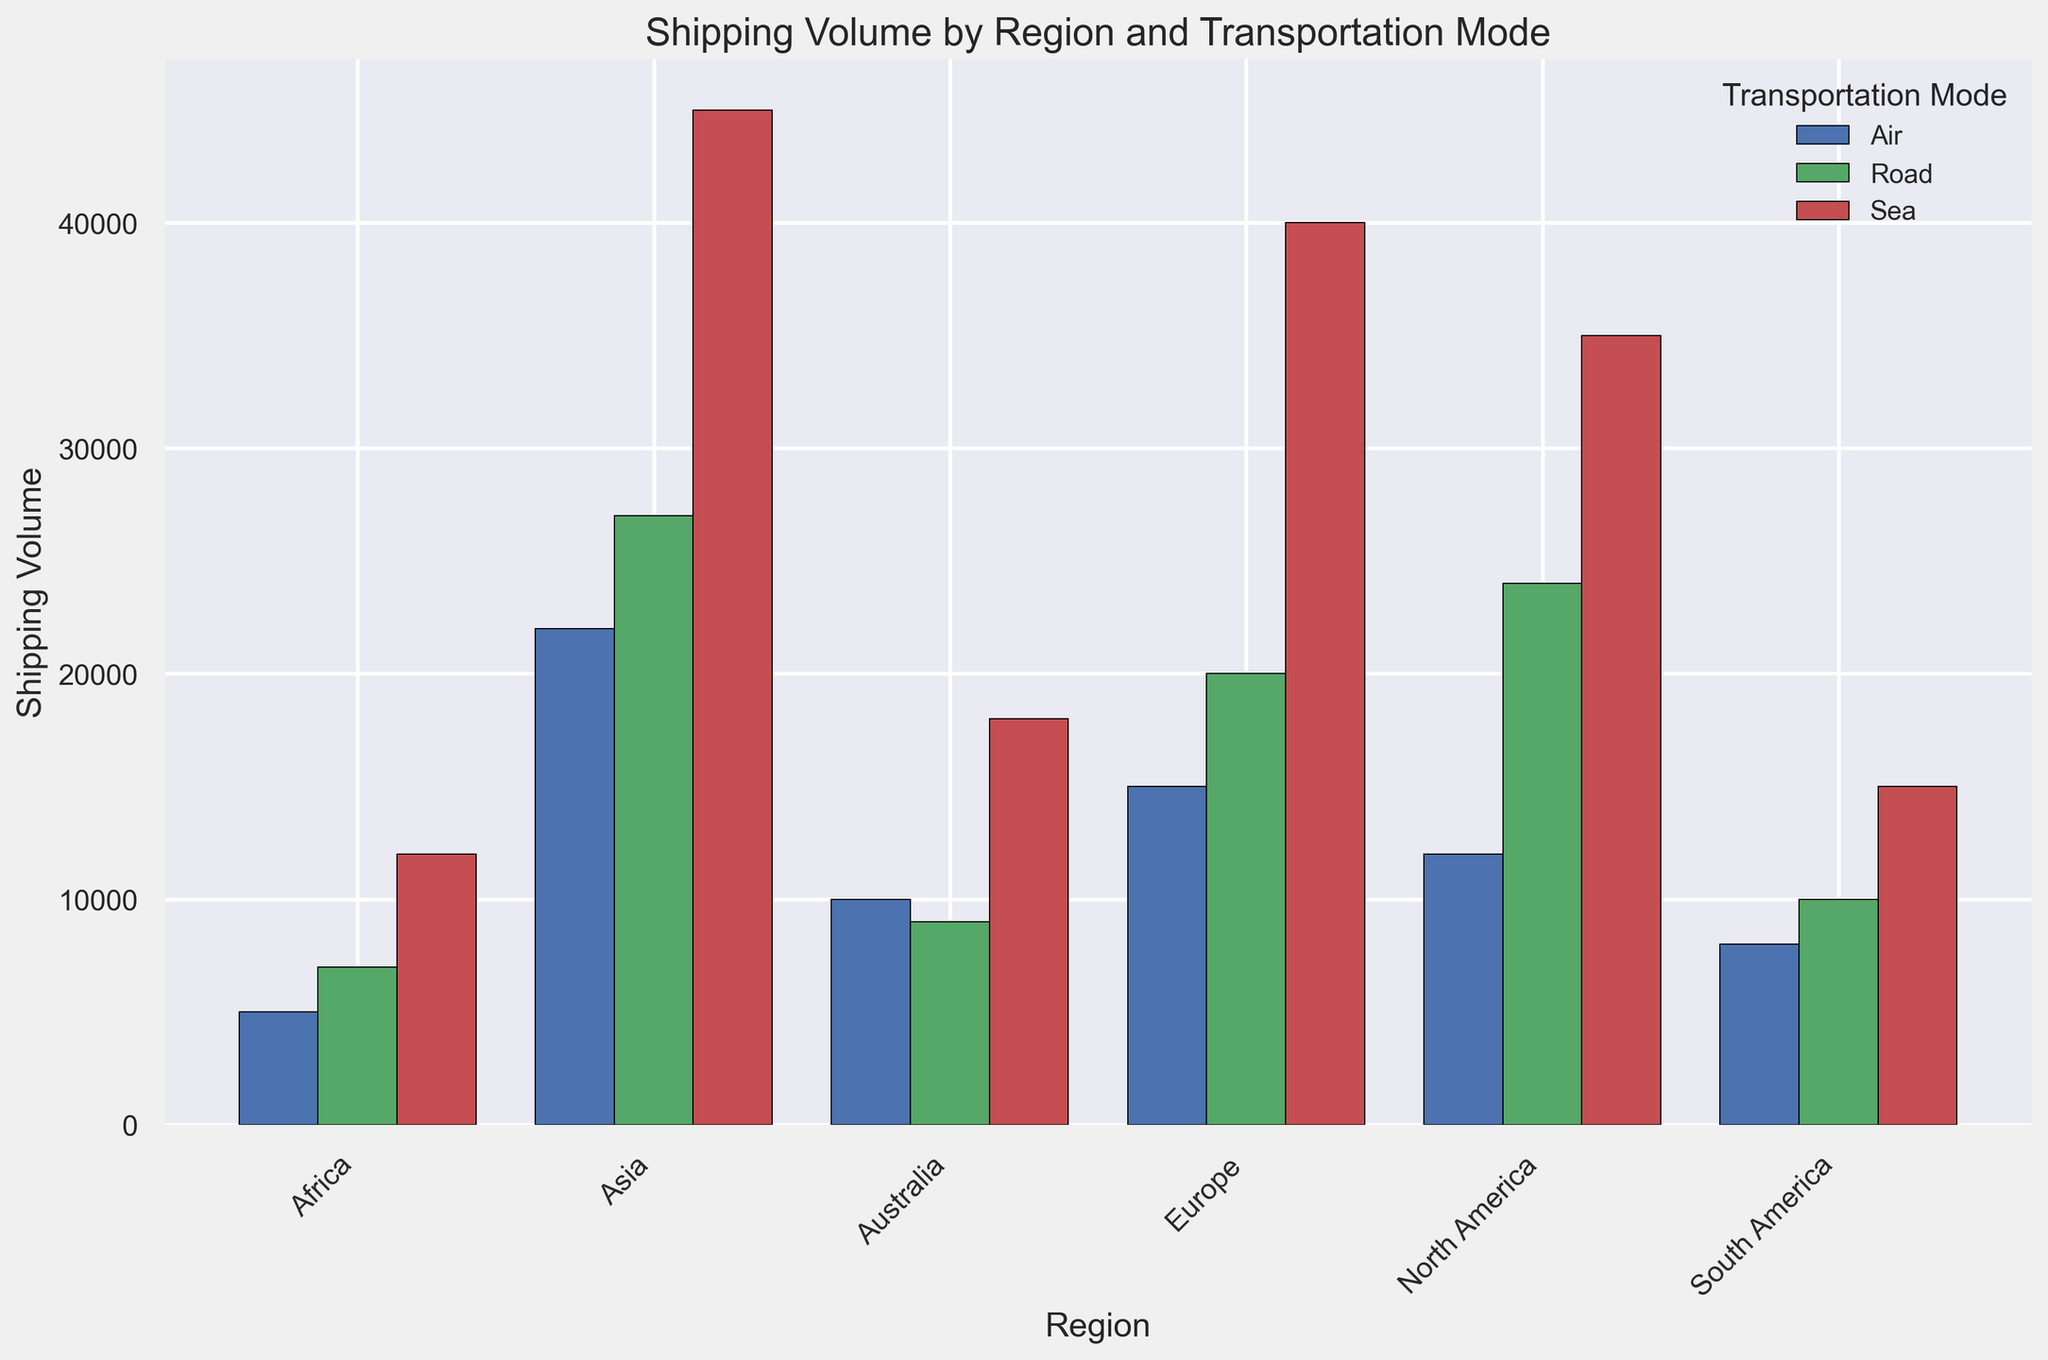Which region has the highest shipping volume overall? To find the region with the highest shipping volume overall, add up the volumes for Air, Sea, and Road within each region. North America: 12000 + 35000 + 24000 = 71000, Europe: 15000 + 40000 + 20000 = 75000, Asia: 22000 + 45000 + 27000 = 94000, South America: 8000 + 15000 + 10000 = 33000, Africa: 5000 + 12000 + 7000 = 24000, Australia: 10000 + 18000 + 9000 = 37000. Asia has the highest overall volume with 94000.
Answer: Asia Which transportation mode has the highest volume in Europe? Look at the bar representing Europe and compare the heights of the bars for Air, Sea, and Road. Sea has the highest bar in Europe.
Answer: Sea What is the difference in total shipping volume between Asia and Africa? First, calculate the total shipping volumes for Asia and Africa. Asia: 22000 (Air) + 45000 (Sea) + 27000 (Road) = 94000. Africa: 5000 (Air) + 12000 (Sea) + 7000 (Road) = 24000. The difference is 94000 - 24000 = 70000.
Answer: 70000 What is the average shipping volume per transportation mode for North America? Add the volumes for Air, Sea, and Road in North America and then divide by 3. (12000 + 35000 + 24000) / 3 = 71000 / 3 = 23666.67.
Answer: 23666.67 Which region has the lowest volume for Air transportation? Compare the heights of the Air transportation bar for all regions. Africa has the lowest bar for Air transportation.
Answer: Africa Which regions have a Sea transportation volume greater than 30000? Compare the Sea transportation bars for each region with the height representing 30000. North America (35000), Europe (40000), and Asia (45000) all have Sea transportation volumes greater than 30000.
Answer: North America, Europe, Asia How does South America's total shipping volume compare to Australia's? Calculate the total shipping volumes for South America and Australia. South America: 8000 (Air) + 15000 (Sea) + 10000 (Road) = 33000. Australia: 10000 (Air) + 18000 (Sea) + 9000 (Road) = 37000. Compare 33000 and 37000 to find South America has less than Australia.
Answer: Less than Australia What's the total shipping volume for Road transportation across all regions? Add up the Road volumes for all regions: North America (24000) + Europe (20000) + Asia (27000) + South America (10000) + Africa (7000) + Australia (9000). 24000 + 20000 + 27000 + 10000 + 7000 + 9000 = 97000.
Answer: 97000 What's the sum of Sea transportation volumes for Europe and Asia? Add the Sea transportation volumes for Europe and Asia. Europe: 40000, Asia: 45000. The sum is 40000 + 45000 = 85000.
Answer: 85000 